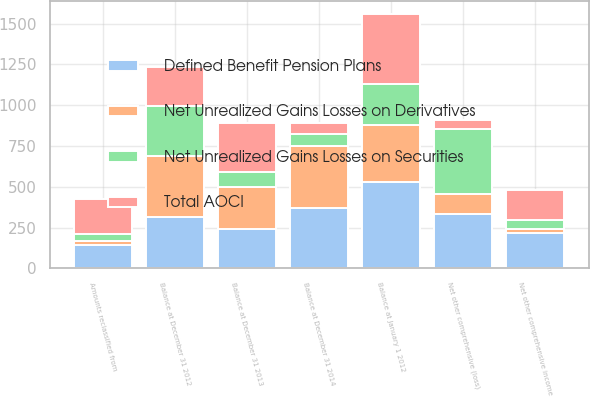Convert chart to OTSL. <chart><loc_0><loc_0><loc_500><loc_500><stacked_bar_chart><ecel><fcel>Balance at January 1 2012<fcel>Amounts reclassified from<fcel>Net other comprehensive income<fcel>Balance at December 31 2012<fcel>Net other comprehensive (loss)<fcel>Balance at December 31 2013<fcel>Balance at December 31 2014<nl><fcel>Total AOCI<fcel>426<fcel>212<fcel>186<fcel>240<fcel>58<fcel>298<fcel>69<nl><fcel>Net Unrealized Gains Losses on Securities<fcel>251<fcel>45<fcel>55<fcel>306<fcel>397<fcel>91<fcel>74<nl><fcel>Net Unrealized Gains Losses on Derivatives<fcel>353<fcel>25<fcel>25<fcel>378<fcel>119<fcel>259<fcel>377<nl><fcel>Defined Benefit Pension Plans<fcel>528<fcel>142<fcel>216<fcel>312<fcel>336<fcel>240<fcel>372<nl></chart> 